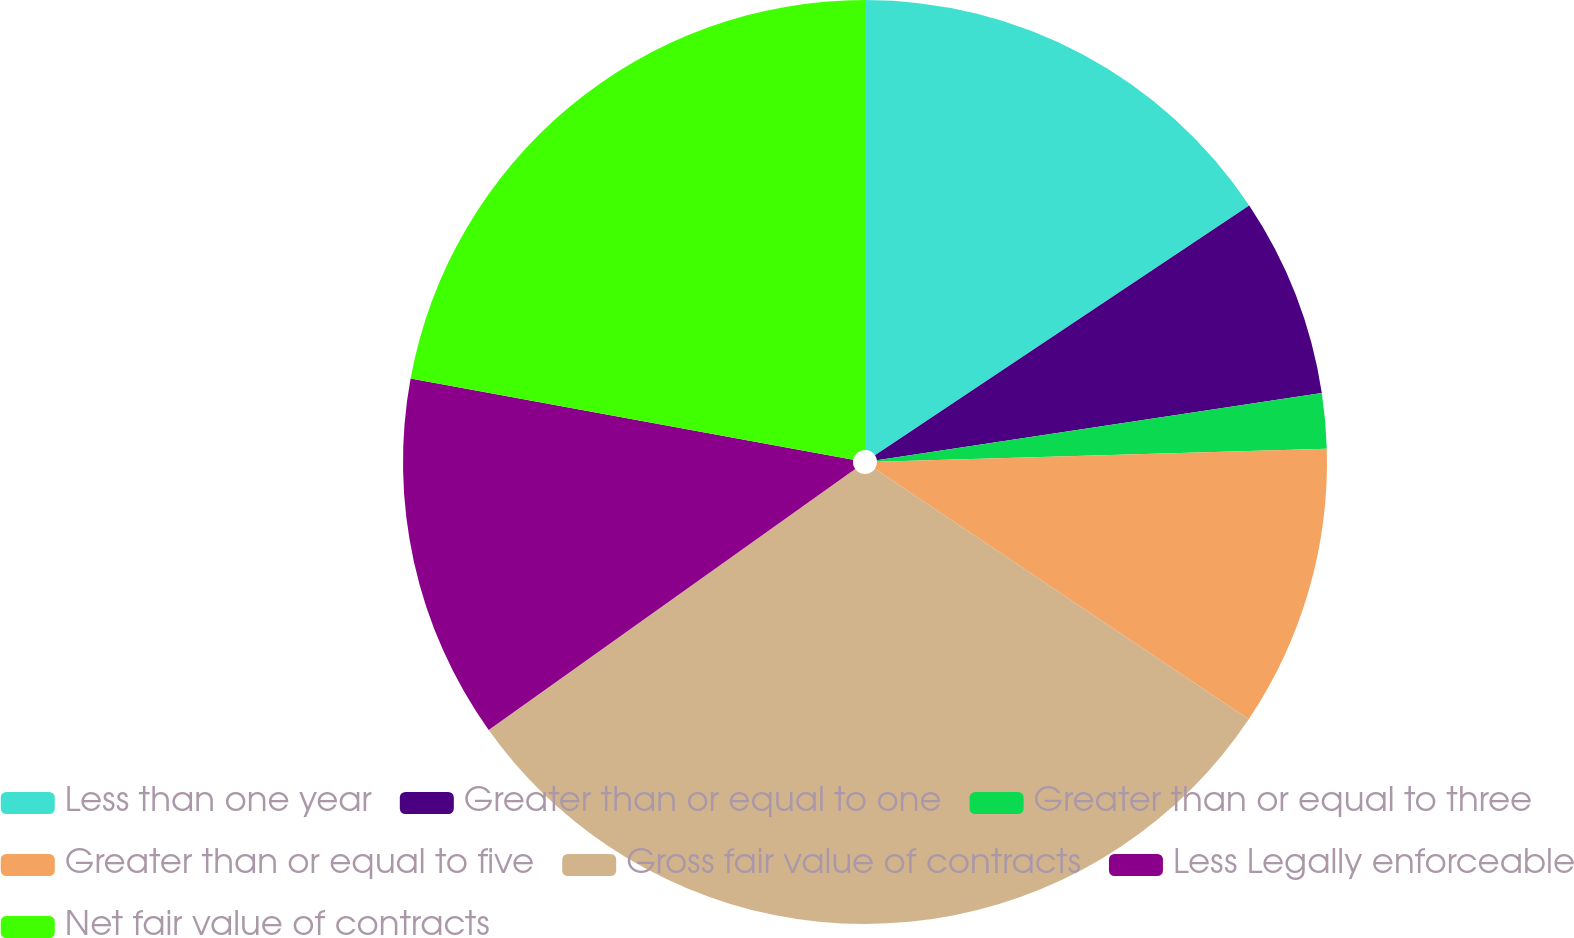<chart> <loc_0><loc_0><loc_500><loc_500><pie_chart><fcel>Less than one year<fcel>Greater than or equal to one<fcel>Greater than or equal to three<fcel>Greater than or equal to five<fcel>Gross fair value of contracts<fcel>Less Legally enforceable<fcel>Net fair value of contracts<nl><fcel>15.63%<fcel>6.98%<fcel>1.93%<fcel>9.86%<fcel>30.75%<fcel>12.74%<fcel>22.11%<nl></chart> 